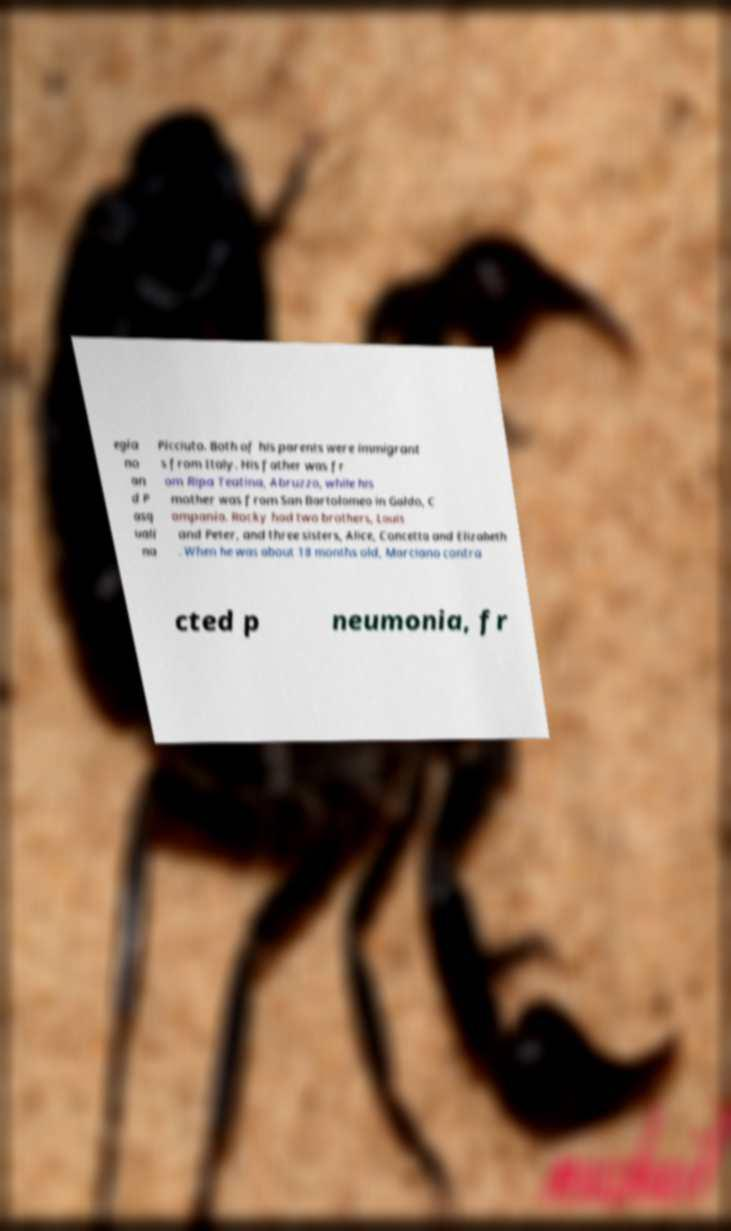What messages or text are displayed in this image? I need them in a readable, typed format. egia no an d P asq uali na Picciuto. Both of his parents were immigrant s from Italy. His father was fr om Ripa Teatina, Abruzzo, while his mother was from San Bartolomeo in Galdo, C ampania. Rocky had two brothers, Louis and Peter, and three sisters, Alice, Concetta and Elizabeth . When he was about 18 months old, Marciano contra cted p neumonia, fr 